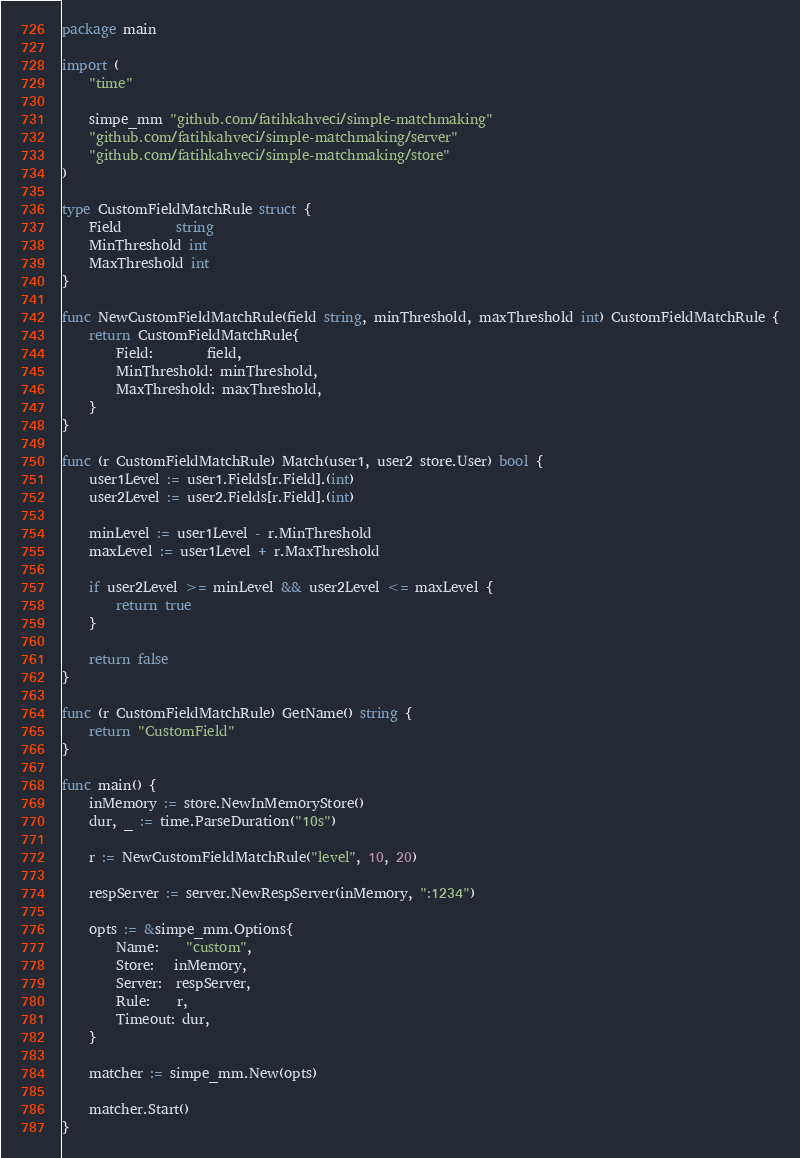<code> <loc_0><loc_0><loc_500><loc_500><_Go_>package main

import (
	"time"

	simpe_mm "github.com/fatihkahveci/simple-matchmaking"
	"github.com/fatihkahveci/simple-matchmaking/server"
	"github.com/fatihkahveci/simple-matchmaking/store"
)

type CustomFieldMatchRule struct {
	Field        string
	MinThreshold int
	MaxThreshold int
}

func NewCustomFieldMatchRule(field string, minThreshold, maxThreshold int) CustomFieldMatchRule {
	return CustomFieldMatchRule{
		Field:        field,
		MinThreshold: minThreshold,
		MaxThreshold: maxThreshold,
	}
}

func (r CustomFieldMatchRule) Match(user1, user2 store.User) bool {
	user1Level := user1.Fields[r.Field].(int)
	user2Level := user2.Fields[r.Field].(int)

	minLevel := user1Level - r.MinThreshold
	maxLevel := user1Level + r.MaxThreshold

	if user2Level >= minLevel && user2Level <= maxLevel {
		return true
	}

	return false
}

func (r CustomFieldMatchRule) GetName() string {
	return "CustomField"
}

func main() {
	inMemory := store.NewInMemoryStore()
	dur, _ := time.ParseDuration("10s")

	r := NewCustomFieldMatchRule("level", 10, 20)

	respServer := server.NewRespServer(inMemory, ":1234")

	opts := &simpe_mm.Options{
		Name:    "custom",
		Store:   inMemory,
		Server:  respServer,
		Rule:    r,
		Timeout: dur,
	}

	matcher := simpe_mm.New(opts)

	matcher.Start()
}
</code> 